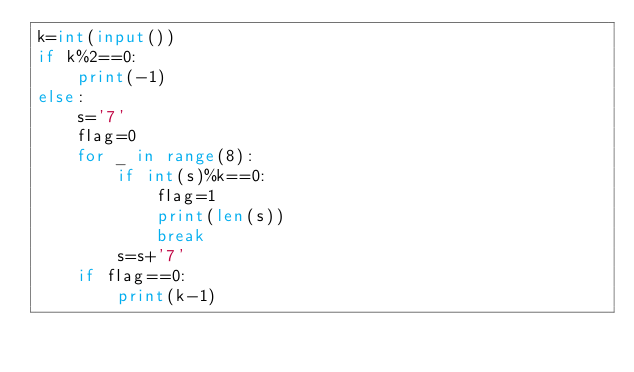Convert code to text. <code><loc_0><loc_0><loc_500><loc_500><_Python_>k=int(input())
if k%2==0:
    print(-1)
else:
    s='7'
    flag=0
    for _ in range(8):
        if int(s)%k==0:
            flag=1
            print(len(s))
            break
        s=s+'7'
    if flag==0:
        print(k-1)</code> 